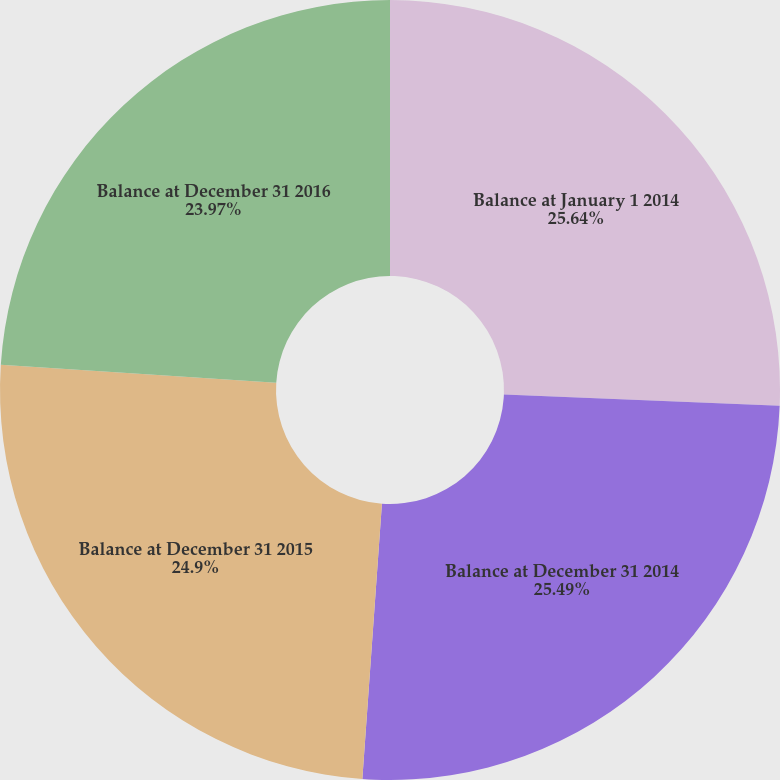Convert chart to OTSL. <chart><loc_0><loc_0><loc_500><loc_500><pie_chart><fcel>Balance at January 1 2014<fcel>Balance at December 31 2014<fcel>Balance at December 31 2015<fcel>Balance at December 31 2016<nl><fcel>25.64%<fcel>25.49%<fcel>24.9%<fcel>23.97%<nl></chart> 